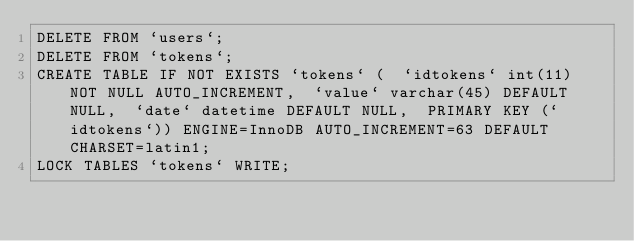Convert code to text. <code><loc_0><loc_0><loc_500><loc_500><_SQL_>DELETE FROM `users`;
DELETE FROM `tokens`;
CREATE TABLE IF NOT EXISTS `tokens` (  `idtokens` int(11) NOT NULL AUTO_INCREMENT,  `value` varchar(45) DEFAULT NULL,  `date` datetime DEFAULT NULL,  PRIMARY KEY (`idtokens`)) ENGINE=InnoDB AUTO_INCREMENT=63 DEFAULT CHARSET=latin1;
LOCK TABLES `tokens` WRITE;</code> 